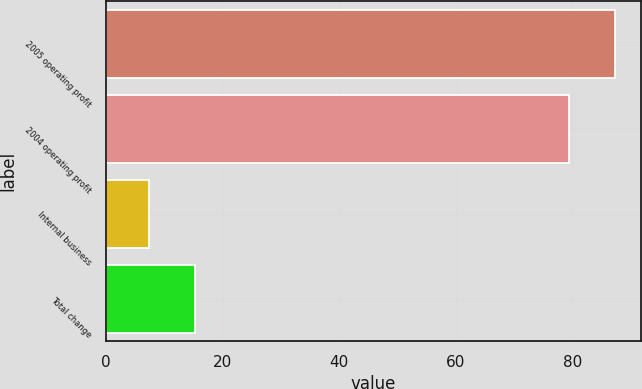<chart> <loc_0><loc_0><loc_500><loc_500><bar_chart><fcel>2005 operating profit<fcel>2004 operating profit<fcel>Internal business<fcel>Total change<nl><fcel>87.36<fcel>79.5<fcel>7.4<fcel>15.26<nl></chart> 